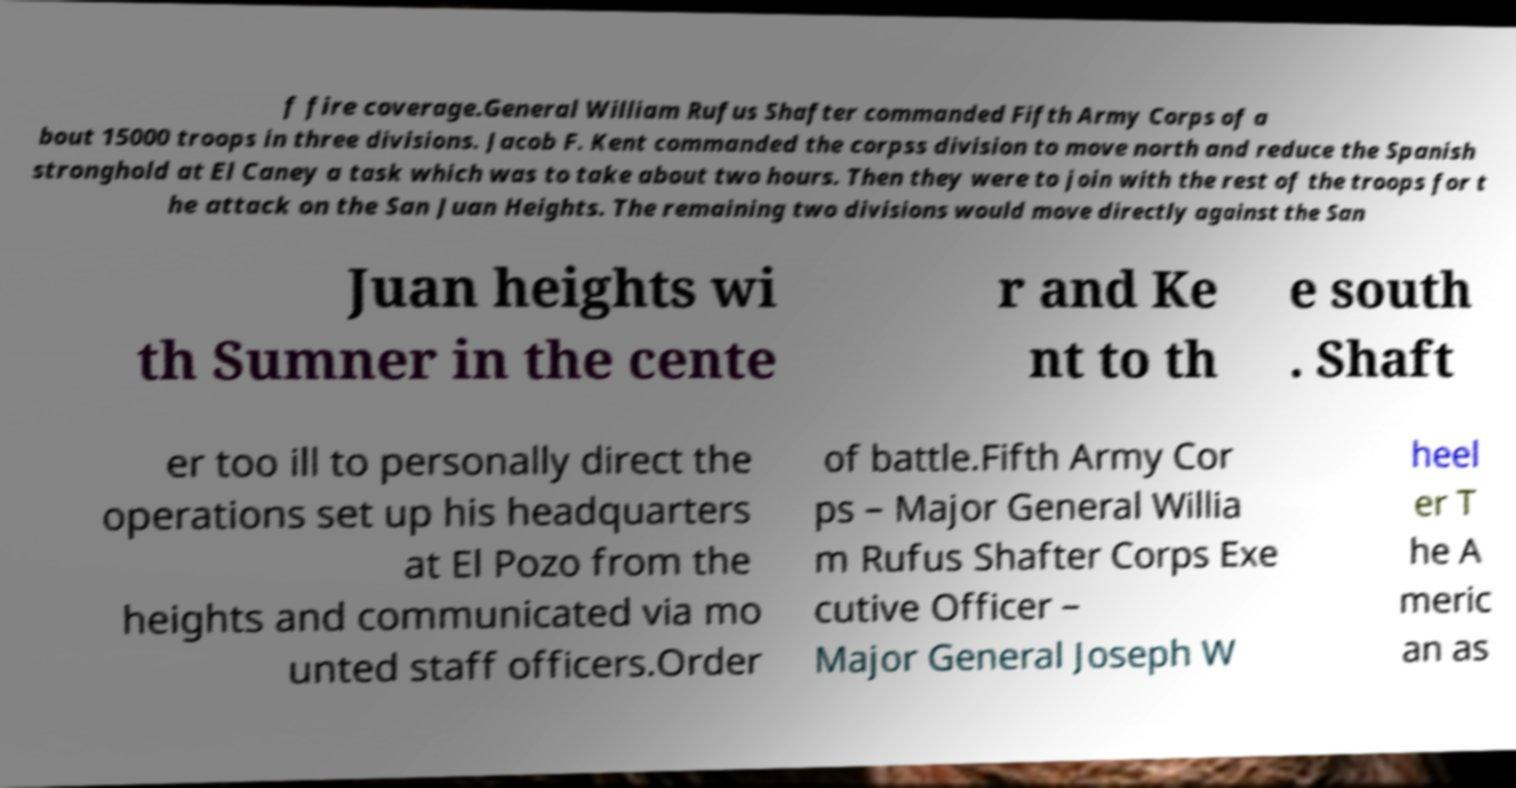Can you read and provide the text displayed in the image?This photo seems to have some interesting text. Can you extract and type it out for me? f fire coverage.General William Rufus Shafter commanded Fifth Army Corps of a bout 15000 troops in three divisions. Jacob F. Kent commanded the corpss division to move north and reduce the Spanish stronghold at El Caney a task which was to take about two hours. Then they were to join with the rest of the troops for t he attack on the San Juan Heights. The remaining two divisions would move directly against the San Juan heights wi th Sumner in the cente r and Ke nt to th e south . Shaft er too ill to personally direct the operations set up his headquarters at El Pozo from the heights and communicated via mo unted staff officers.Order of battle.Fifth Army Cor ps – Major General Willia m Rufus Shafter Corps Exe cutive Officer – Major General Joseph W heel er T he A meric an as 